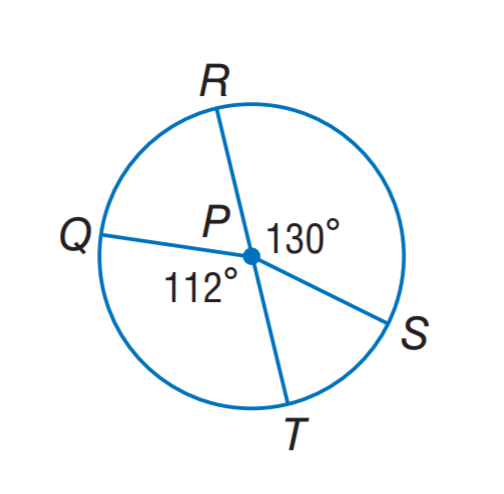Answer the mathemtical geometry problem and directly provide the correct option letter.
Question: In \odot P, R T = 11, find m \widehat Q R S. Round to the nearest hundredth.
Choices: A: 15.55 B: 19.01 C: 31.10 D: 38.01 B 